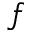Convert formula to latex. <formula><loc_0><loc_0><loc_500><loc_500>f</formula> 